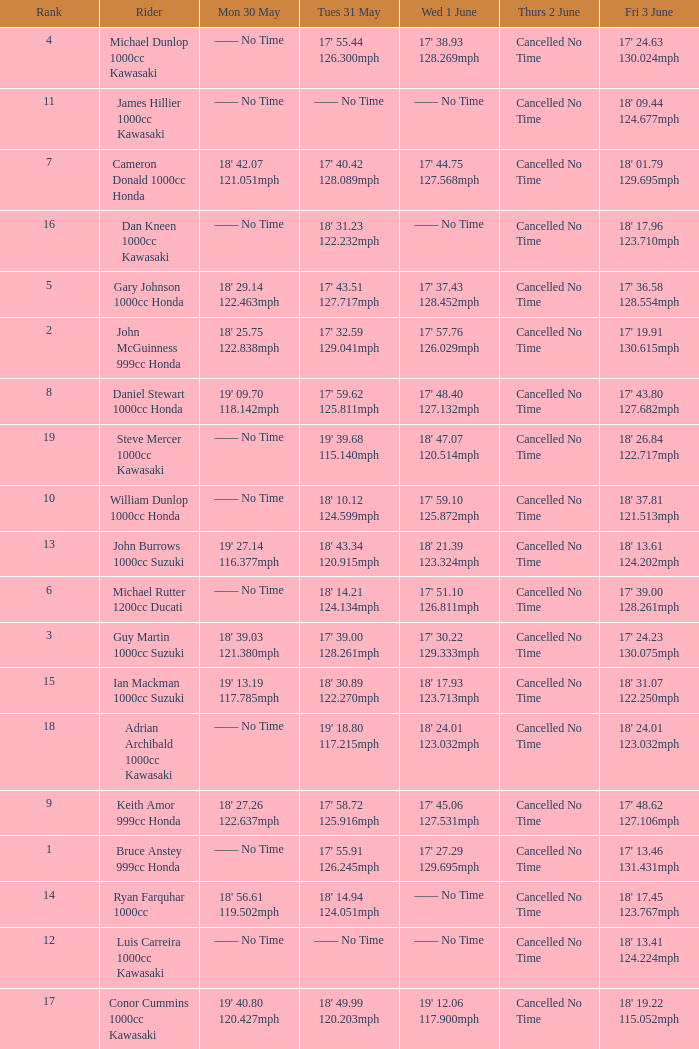What is the Fri 3 June time for the rider whose Tues 31 May time was 19' 18.80 117.215mph? 18' 24.01 123.032mph. 